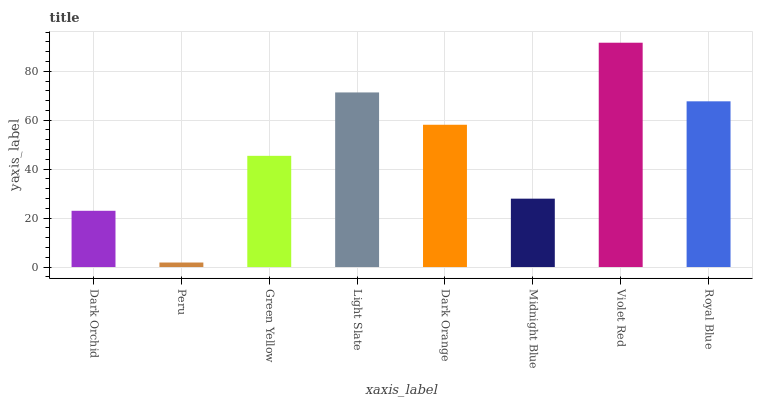Is Peru the minimum?
Answer yes or no. Yes. Is Violet Red the maximum?
Answer yes or no. Yes. Is Green Yellow the minimum?
Answer yes or no. No. Is Green Yellow the maximum?
Answer yes or no. No. Is Green Yellow greater than Peru?
Answer yes or no. Yes. Is Peru less than Green Yellow?
Answer yes or no. Yes. Is Peru greater than Green Yellow?
Answer yes or no. No. Is Green Yellow less than Peru?
Answer yes or no. No. Is Dark Orange the high median?
Answer yes or no. Yes. Is Green Yellow the low median?
Answer yes or no. Yes. Is Midnight Blue the high median?
Answer yes or no. No. Is Violet Red the low median?
Answer yes or no. No. 